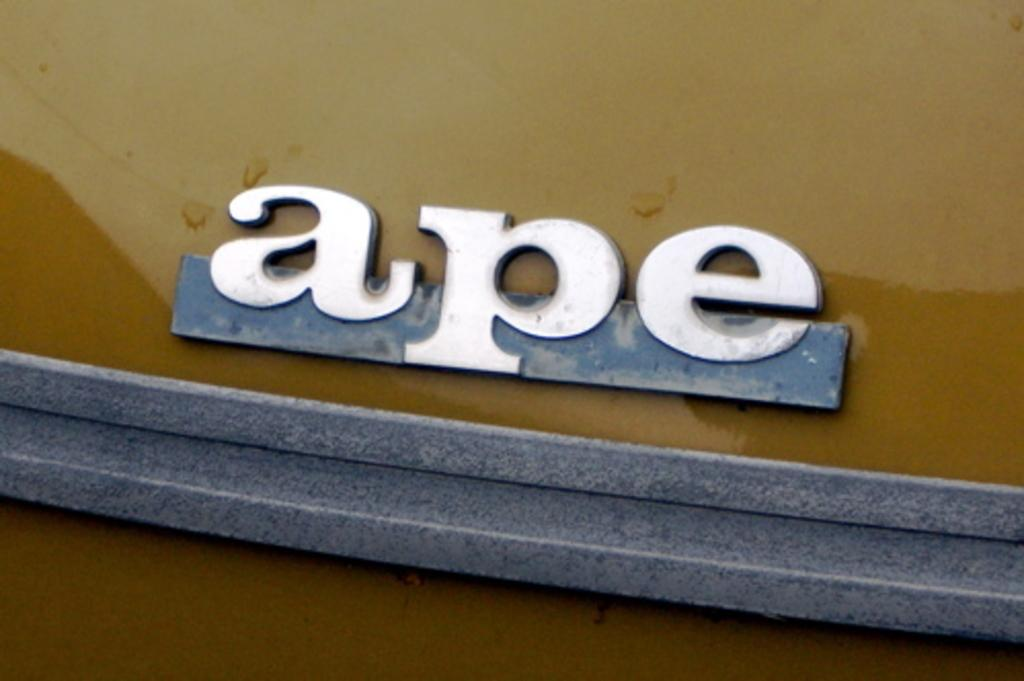What is attached to the vehicle in the image? There is a name board attached to a vehicle in the image. What type of bone can be seen in the image? There is no bone present in the image; it features a name board attached to a vehicle. Is there a knife visible in the image? No, there is no knife present in the image. 